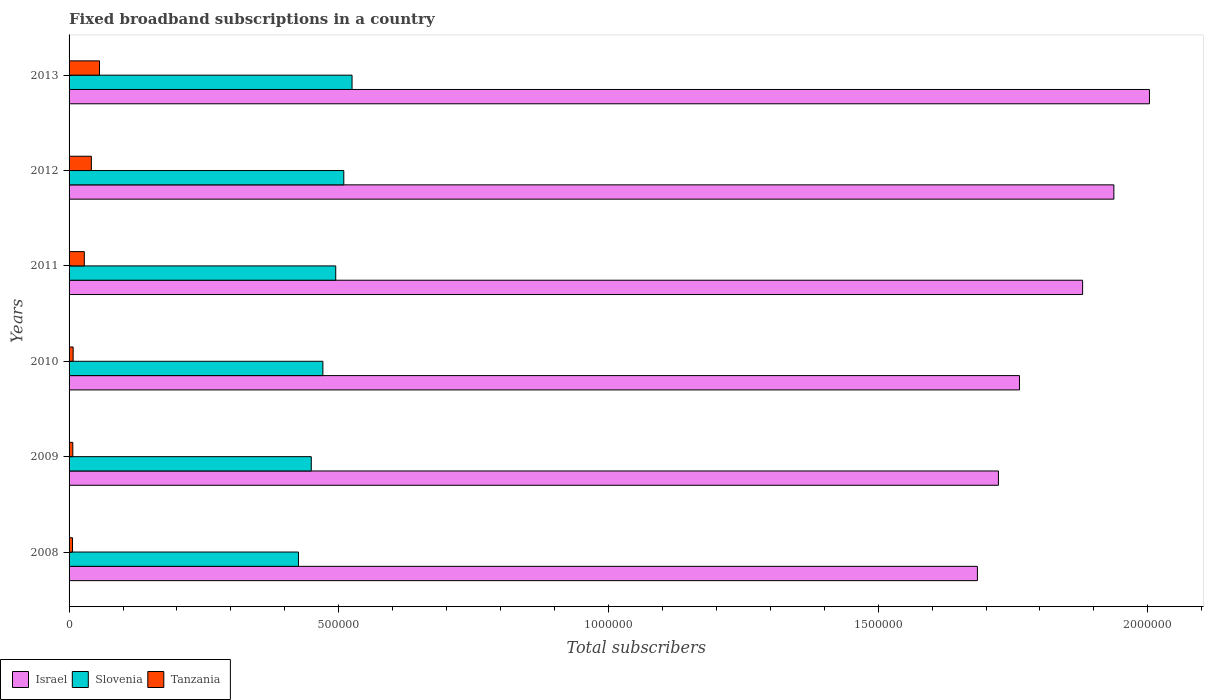How many different coloured bars are there?
Offer a terse response. 3. How many groups of bars are there?
Provide a succinct answer. 6. How many bars are there on the 6th tick from the bottom?
Give a very brief answer. 3. What is the number of broadband subscriptions in Israel in 2013?
Your answer should be very brief. 2.00e+06. Across all years, what is the maximum number of broadband subscriptions in Tanzania?
Your answer should be compact. 5.64e+04. Across all years, what is the minimum number of broadband subscriptions in Slovenia?
Provide a short and direct response. 4.25e+05. In which year was the number of broadband subscriptions in Israel minimum?
Your answer should be compact. 2008. What is the total number of broadband subscriptions in Slovenia in the graph?
Give a very brief answer. 2.87e+06. What is the difference between the number of broadband subscriptions in Slovenia in 2012 and that in 2013?
Make the answer very short. -1.53e+04. What is the difference between the number of broadband subscriptions in Slovenia in 2010 and the number of broadband subscriptions in Tanzania in 2012?
Give a very brief answer. 4.29e+05. What is the average number of broadband subscriptions in Israel per year?
Your answer should be compact. 1.83e+06. In the year 2009, what is the difference between the number of broadband subscriptions in Tanzania and number of broadband subscriptions in Slovenia?
Keep it short and to the point. -4.42e+05. In how many years, is the number of broadband subscriptions in Israel greater than 700000 ?
Provide a short and direct response. 6. What is the ratio of the number of broadband subscriptions in Israel in 2008 to that in 2010?
Provide a short and direct response. 0.96. What is the difference between the highest and the second highest number of broadband subscriptions in Israel?
Make the answer very short. 6.60e+04. What is the difference between the highest and the lowest number of broadband subscriptions in Slovenia?
Offer a very short reply. 9.93e+04. Is the sum of the number of broadband subscriptions in Tanzania in 2010 and 2013 greater than the maximum number of broadband subscriptions in Slovenia across all years?
Provide a succinct answer. No. What does the 2nd bar from the top in 2010 represents?
Keep it short and to the point. Slovenia. What does the 3rd bar from the bottom in 2010 represents?
Offer a very short reply. Tanzania. Are all the bars in the graph horizontal?
Make the answer very short. Yes. What is the difference between two consecutive major ticks on the X-axis?
Your response must be concise. 5.00e+05. Does the graph contain any zero values?
Offer a very short reply. No. Where does the legend appear in the graph?
Your answer should be very brief. Bottom left. What is the title of the graph?
Provide a short and direct response. Fixed broadband subscriptions in a country. Does "Afghanistan" appear as one of the legend labels in the graph?
Provide a short and direct response. No. What is the label or title of the X-axis?
Offer a terse response. Total subscribers. What is the Total subscribers in Israel in 2008?
Provide a short and direct response. 1.68e+06. What is the Total subscribers in Slovenia in 2008?
Keep it short and to the point. 4.25e+05. What is the Total subscribers of Tanzania in 2008?
Make the answer very short. 6422. What is the Total subscribers in Israel in 2009?
Provide a short and direct response. 1.72e+06. What is the Total subscribers in Slovenia in 2009?
Ensure brevity in your answer.  4.49e+05. What is the Total subscribers of Tanzania in 2009?
Your answer should be compact. 6947. What is the Total subscribers in Israel in 2010?
Your response must be concise. 1.76e+06. What is the Total subscribers of Slovenia in 2010?
Make the answer very short. 4.71e+05. What is the Total subscribers in Tanzania in 2010?
Give a very brief answer. 7554. What is the Total subscribers of Israel in 2011?
Offer a terse response. 1.88e+06. What is the Total subscribers of Slovenia in 2011?
Your answer should be compact. 4.94e+05. What is the Total subscribers in Tanzania in 2011?
Keep it short and to the point. 2.83e+04. What is the Total subscribers of Israel in 2012?
Offer a terse response. 1.94e+06. What is the Total subscribers in Slovenia in 2012?
Give a very brief answer. 5.09e+05. What is the Total subscribers in Tanzania in 2012?
Your answer should be compact. 4.13e+04. What is the Total subscribers of Israel in 2013?
Offer a terse response. 2.00e+06. What is the Total subscribers of Slovenia in 2013?
Make the answer very short. 5.25e+05. What is the Total subscribers of Tanzania in 2013?
Offer a terse response. 5.64e+04. Across all years, what is the maximum Total subscribers of Israel?
Your answer should be very brief. 2.00e+06. Across all years, what is the maximum Total subscribers in Slovenia?
Provide a succinct answer. 5.25e+05. Across all years, what is the maximum Total subscribers in Tanzania?
Provide a short and direct response. 5.64e+04. Across all years, what is the minimum Total subscribers in Israel?
Offer a terse response. 1.68e+06. Across all years, what is the minimum Total subscribers in Slovenia?
Provide a succinct answer. 4.25e+05. Across all years, what is the minimum Total subscribers of Tanzania?
Keep it short and to the point. 6422. What is the total Total subscribers of Israel in the graph?
Provide a short and direct response. 1.10e+07. What is the total Total subscribers of Slovenia in the graph?
Give a very brief answer. 2.87e+06. What is the total Total subscribers in Tanzania in the graph?
Your answer should be compact. 1.47e+05. What is the difference between the Total subscribers of Israel in 2008 and that in 2009?
Your response must be concise. -3.90e+04. What is the difference between the Total subscribers of Slovenia in 2008 and that in 2009?
Your answer should be very brief. -2.37e+04. What is the difference between the Total subscribers of Tanzania in 2008 and that in 2009?
Your answer should be very brief. -525. What is the difference between the Total subscribers of Israel in 2008 and that in 2010?
Keep it short and to the point. -7.80e+04. What is the difference between the Total subscribers of Slovenia in 2008 and that in 2010?
Your answer should be very brief. -4.52e+04. What is the difference between the Total subscribers in Tanzania in 2008 and that in 2010?
Offer a terse response. -1132. What is the difference between the Total subscribers in Israel in 2008 and that in 2011?
Provide a succinct answer. -1.95e+05. What is the difference between the Total subscribers of Slovenia in 2008 and that in 2011?
Make the answer very short. -6.91e+04. What is the difference between the Total subscribers of Tanzania in 2008 and that in 2011?
Make the answer very short. -2.18e+04. What is the difference between the Total subscribers in Israel in 2008 and that in 2012?
Provide a short and direct response. -2.53e+05. What is the difference between the Total subscribers of Slovenia in 2008 and that in 2012?
Offer a very short reply. -8.40e+04. What is the difference between the Total subscribers in Tanzania in 2008 and that in 2012?
Make the answer very short. -3.49e+04. What is the difference between the Total subscribers of Israel in 2008 and that in 2013?
Your response must be concise. -3.19e+05. What is the difference between the Total subscribers of Slovenia in 2008 and that in 2013?
Provide a succinct answer. -9.93e+04. What is the difference between the Total subscribers of Tanzania in 2008 and that in 2013?
Your answer should be compact. -5.00e+04. What is the difference between the Total subscribers in Israel in 2009 and that in 2010?
Offer a very short reply. -3.90e+04. What is the difference between the Total subscribers of Slovenia in 2009 and that in 2010?
Offer a very short reply. -2.15e+04. What is the difference between the Total subscribers in Tanzania in 2009 and that in 2010?
Ensure brevity in your answer.  -607. What is the difference between the Total subscribers in Israel in 2009 and that in 2011?
Your answer should be very brief. -1.56e+05. What is the difference between the Total subscribers in Slovenia in 2009 and that in 2011?
Keep it short and to the point. -4.53e+04. What is the difference between the Total subscribers in Tanzania in 2009 and that in 2011?
Offer a terse response. -2.13e+04. What is the difference between the Total subscribers of Israel in 2009 and that in 2012?
Give a very brief answer. -2.14e+05. What is the difference between the Total subscribers in Slovenia in 2009 and that in 2012?
Your answer should be compact. -6.03e+04. What is the difference between the Total subscribers of Tanzania in 2009 and that in 2012?
Provide a succinct answer. -3.44e+04. What is the difference between the Total subscribers of Israel in 2009 and that in 2013?
Your answer should be very brief. -2.80e+05. What is the difference between the Total subscribers of Slovenia in 2009 and that in 2013?
Give a very brief answer. -7.56e+04. What is the difference between the Total subscribers in Tanzania in 2009 and that in 2013?
Your response must be concise. -4.95e+04. What is the difference between the Total subscribers of Israel in 2010 and that in 2011?
Ensure brevity in your answer.  -1.17e+05. What is the difference between the Total subscribers in Slovenia in 2010 and that in 2011?
Your answer should be very brief. -2.38e+04. What is the difference between the Total subscribers of Tanzania in 2010 and that in 2011?
Offer a very short reply. -2.07e+04. What is the difference between the Total subscribers in Israel in 2010 and that in 2012?
Provide a succinct answer. -1.75e+05. What is the difference between the Total subscribers of Slovenia in 2010 and that in 2012?
Provide a succinct answer. -3.88e+04. What is the difference between the Total subscribers in Tanzania in 2010 and that in 2012?
Offer a very short reply. -3.38e+04. What is the difference between the Total subscribers of Israel in 2010 and that in 2013?
Offer a very short reply. -2.41e+05. What is the difference between the Total subscribers in Slovenia in 2010 and that in 2013?
Offer a very short reply. -5.41e+04. What is the difference between the Total subscribers of Tanzania in 2010 and that in 2013?
Your response must be concise. -4.89e+04. What is the difference between the Total subscribers in Israel in 2011 and that in 2012?
Your response must be concise. -5.80e+04. What is the difference between the Total subscribers of Slovenia in 2011 and that in 2012?
Provide a short and direct response. -1.50e+04. What is the difference between the Total subscribers in Tanzania in 2011 and that in 2012?
Your answer should be very brief. -1.31e+04. What is the difference between the Total subscribers in Israel in 2011 and that in 2013?
Provide a succinct answer. -1.24e+05. What is the difference between the Total subscribers in Slovenia in 2011 and that in 2013?
Offer a very short reply. -3.02e+04. What is the difference between the Total subscribers in Tanzania in 2011 and that in 2013?
Offer a terse response. -2.82e+04. What is the difference between the Total subscribers of Israel in 2012 and that in 2013?
Offer a terse response. -6.60e+04. What is the difference between the Total subscribers of Slovenia in 2012 and that in 2013?
Ensure brevity in your answer.  -1.53e+04. What is the difference between the Total subscribers in Tanzania in 2012 and that in 2013?
Provide a succinct answer. -1.51e+04. What is the difference between the Total subscribers of Israel in 2008 and the Total subscribers of Slovenia in 2009?
Keep it short and to the point. 1.23e+06. What is the difference between the Total subscribers of Israel in 2008 and the Total subscribers of Tanzania in 2009?
Ensure brevity in your answer.  1.68e+06. What is the difference between the Total subscribers of Slovenia in 2008 and the Total subscribers of Tanzania in 2009?
Provide a succinct answer. 4.18e+05. What is the difference between the Total subscribers of Israel in 2008 and the Total subscribers of Slovenia in 2010?
Your answer should be very brief. 1.21e+06. What is the difference between the Total subscribers of Israel in 2008 and the Total subscribers of Tanzania in 2010?
Provide a short and direct response. 1.68e+06. What is the difference between the Total subscribers of Slovenia in 2008 and the Total subscribers of Tanzania in 2010?
Give a very brief answer. 4.18e+05. What is the difference between the Total subscribers in Israel in 2008 and the Total subscribers in Slovenia in 2011?
Provide a succinct answer. 1.19e+06. What is the difference between the Total subscribers in Israel in 2008 and the Total subscribers in Tanzania in 2011?
Provide a short and direct response. 1.66e+06. What is the difference between the Total subscribers of Slovenia in 2008 and the Total subscribers of Tanzania in 2011?
Keep it short and to the point. 3.97e+05. What is the difference between the Total subscribers in Israel in 2008 and the Total subscribers in Slovenia in 2012?
Provide a succinct answer. 1.17e+06. What is the difference between the Total subscribers in Israel in 2008 and the Total subscribers in Tanzania in 2012?
Give a very brief answer. 1.64e+06. What is the difference between the Total subscribers of Slovenia in 2008 and the Total subscribers of Tanzania in 2012?
Your response must be concise. 3.84e+05. What is the difference between the Total subscribers of Israel in 2008 and the Total subscribers of Slovenia in 2013?
Offer a very short reply. 1.16e+06. What is the difference between the Total subscribers of Israel in 2008 and the Total subscribers of Tanzania in 2013?
Offer a terse response. 1.63e+06. What is the difference between the Total subscribers of Slovenia in 2008 and the Total subscribers of Tanzania in 2013?
Your answer should be very brief. 3.69e+05. What is the difference between the Total subscribers in Israel in 2009 and the Total subscribers in Slovenia in 2010?
Your answer should be very brief. 1.25e+06. What is the difference between the Total subscribers in Israel in 2009 and the Total subscribers in Tanzania in 2010?
Give a very brief answer. 1.72e+06. What is the difference between the Total subscribers in Slovenia in 2009 and the Total subscribers in Tanzania in 2010?
Keep it short and to the point. 4.41e+05. What is the difference between the Total subscribers of Israel in 2009 and the Total subscribers of Slovenia in 2011?
Your answer should be compact. 1.23e+06. What is the difference between the Total subscribers in Israel in 2009 and the Total subscribers in Tanzania in 2011?
Make the answer very short. 1.69e+06. What is the difference between the Total subscribers in Slovenia in 2009 and the Total subscribers in Tanzania in 2011?
Your answer should be very brief. 4.21e+05. What is the difference between the Total subscribers in Israel in 2009 and the Total subscribers in Slovenia in 2012?
Offer a very short reply. 1.21e+06. What is the difference between the Total subscribers in Israel in 2009 and the Total subscribers in Tanzania in 2012?
Your response must be concise. 1.68e+06. What is the difference between the Total subscribers of Slovenia in 2009 and the Total subscribers of Tanzania in 2012?
Ensure brevity in your answer.  4.08e+05. What is the difference between the Total subscribers of Israel in 2009 and the Total subscribers of Slovenia in 2013?
Your answer should be very brief. 1.20e+06. What is the difference between the Total subscribers of Israel in 2009 and the Total subscribers of Tanzania in 2013?
Provide a short and direct response. 1.67e+06. What is the difference between the Total subscribers of Slovenia in 2009 and the Total subscribers of Tanzania in 2013?
Give a very brief answer. 3.93e+05. What is the difference between the Total subscribers of Israel in 2010 and the Total subscribers of Slovenia in 2011?
Your response must be concise. 1.27e+06. What is the difference between the Total subscribers in Israel in 2010 and the Total subscribers in Tanzania in 2011?
Offer a terse response. 1.73e+06. What is the difference between the Total subscribers of Slovenia in 2010 and the Total subscribers of Tanzania in 2011?
Ensure brevity in your answer.  4.42e+05. What is the difference between the Total subscribers in Israel in 2010 and the Total subscribers in Slovenia in 2012?
Ensure brevity in your answer.  1.25e+06. What is the difference between the Total subscribers in Israel in 2010 and the Total subscribers in Tanzania in 2012?
Keep it short and to the point. 1.72e+06. What is the difference between the Total subscribers in Slovenia in 2010 and the Total subscribers in Tanzania in 2012?
Offer a terse response. 4.29e+05. What is the difference between the Total subscribers of Israel in 2010 and the Total subscribers of Slovenia in 2013?
Provide a short and direct response. 1.24e+06. What is the difference between the Total subscribers of Israel in 2010 and the Total subscribers of Tanzania in 2013?
Provide a succinct answer. 1.71e+06. What is the difference between the Total subscribers of Slovenia in 2010 and the Total subscribers of Tanzania in 2013?
Provide a short and direct response. 4.14e+05. What is the difference between the Total subscribers in Israel in 2011 and the Total subscribers in Slovenia in 2012?
Your answer should be compact. 1.37e+06. What is the difference between the Total subscribers in Israel in 2011 and the Total subscribers in Tanzania in 2012?
Give a very brief answer. 1.84e+06. What is the difference between the Total subscribers of Slovenia in 2011 and the Total subscribers of Tanzania in 2012?
Offer a terse response. 4.53e+05. What is the difference between the Total subscribers in Israel in 2011 and the Total subscribers in Slovenia in 2013?
Your answer should be very brief. 1.35e+06. What is the difference between the Total subscribers of Israel in 2011 and the Total subscribers of Tanzania in 2013?
Ensure brevity in your answer.  1.82e+06. What is the difference between the Total subscribers in Slovenia in 2011 and the Total subscribers in Tanzania in 2013?
Keep it short and to the point. 4.38e+05. What is the difference between the Total subscribers in Israel in 2012 and the Total subscribers in Slovenia in 2013?
Provide a succinct answer. 1.41e+06. What is the difference between the Total subscribers of Israel in 2012 and the Total subscribers of Tanzania in 2013?
Keep it short and to the point. 1.88e+06. What is the difference between the Total subscribers of Slovenia in 2012 and the Total subscribers of Tanzania in 2013?
Offer a very short reply. 4.53e+05. What is the average Total subscribers in Israel per year?
Give a very brief answer. 1.83e+06. What is the average Total subscribers of Slovenia per year?
Offer a very short reply. 4.79e+05. What is the average Total subscribers of Tanzania per year?
Give a very brief answer. 2.45e+04. In the year 2008, what is the difference between the Total subscribers in Israel and Total subscribers in Slovenia?
Your response must be concise. 1.26e+06. In the year 2008, what is the difference between the Total subscribers of Israel and Total subscribers of Tanzania?
Give a very brief answer. 1.68e+06. In the year 2008, what is the difference between the Total subscribers of Slovenia and Total subscribers of Tanzania?
Give a very brief answer. 4.19e+05. In the year 2009, what is the difference between the Total subscribers of Israel and Total subscribers of Slovenia?
Provide a short and direct response. 1.27e+06. In the year 2009, what is the difference between the Total subscribers in Israel and Total subscribers in Tanzania?
Your answer should be very brief. 1.72e+06. In the year 2009, what is the difference between the Total subscribers in Slovenia and Total subscribers in Tanzania?
Ensure brevity in your answer.  4.42e+05. In the year 2010, what is the difference between the Total subscribers of Israel and Total subscribers of Slovenia?
Your answer should be very brief. 1.29e+06. In the year 2010, what is the difference between the Total subscribers of Israel and Total subscribers of Tanzania?
Keep it short and to the point. 1.75e+06. In the year 2010, what is the difference between the Total subscribers in Slovenia and Total subscribers in Tanzania?
Provide a short and direct response. 4.63e+05. In the year 2011, what is the difference between the Total subscribers of Israel and Total subscribers of Slovenia?
Your answer should be very brief. 1.38e+06. In the year 2011, what is the difference between the Total subscribers of Israel and Total subscribers of Tanzania?
Your answer should be very brief. 1.85e+06. In the year 2011, what is the difference between the Total subscribers in Slovenia and Total subscribers in Tanzania?
Your response must be concise. 4.66e+05. In the year 2012, what is the difference between the Total subscribers of Israel and Total subscribers of Slovenia?
Provide a short and direct response. 1.43e+06. In the year 2012, what is the difference between the Total subscribers in Israel and Total subscribers in Tanzania?
Make the answer very short. 1.90e+06. In the year 2012, what is the difference between the Total subscribers in Slovenia and Total subscribers in Tanzania?
Give a very brief answer. 4.68e+05. In the year 2013, what is the difference between the Total subscribers in Israel and Total subscribers in Slovenia?
Offer a very short reply. 1.48e+06. In the year 2013, what is the difference between the Total subscribers of Israel and Total subscribers of Tanzania?
Make the answer very short. 1.95e+06. In the year 2013, what is the difference between the Total subscribers in Slovenia and Total subscribers in Tanzania?
Your answer should be compact. 4.68e+05. What is the ratio of the Total subscribers in Israel in 2008 to that in 2009?
Provide a succinct answer. 0.98. What is the ratio of the Total subscribers in Slovenia in 2008 to that in 2009?
Ensure brevity in your answer.  0.95. What is the ratio of the Total subscribers in Tanzania in 2008 to that in 2009?
Give a very brief answer. 0.92. What is the ratio of the Total subscribers in Israel in 2008 to that in 2010?
Offer a terse response. 0.96. What is the ratio of the Total subscribers in Slovenia in 2008 to that in 2010?
Your answer should be compact. 0.9. What is the ratio of the Total subscribers in Tanzania in 2008 to that in 2010?
Make the answer very short. 0.85. What is the ratio of the Total subscribers of Israel in 2008 to that in 2011?
Your response must be concise. 0.9. What is the ratio of the Total subscribers of Slovenia in 2008 to that in 2011?
Your response must be concise. 0.86. What is the ratio of the Total subscribers in Tanzania in 2008 to that in 2011?
Give a very brief answer. 0.23. What is the ratio of the Total subscribers in Israel in 2008 to that in 2012?
Your answer should be very brief. 0.87. What is the ratio of the Total subscribers of Slovenia in 2008 to that in 2012?
Make the answer very short. 0.83. What is the ratio of the Total subscribers of Tanzania in 2008 to that in 2012?
Ensure brevity in your answer.  0.16. What is the ratio of the Total subscribers of Israel in 2008 to that in 2013?
Your answer should be compact. 0.84. What is the ratio of the Total subscribers in Slovenia in 2008 to that in 2013?
Your answer should be very brief. 0.81. What is the ratio of the Total subscribers of Tanzania in 2008 to that in 2013?
Your answer should be compact. 0.11. What is the ratio of the Total subscribers of Israel in 2009 to that in 2010?
Your answer should be very brief. 0.98. What is the ratio of the Total subscribers in Slovenia in 2009 to that in 2010?
Make the answer very short. 0.95. What is the ratio of the Total subscribers of Tanzania in 2009 to that in 2010?
Keep it short and to the point. 0.92. What is the ratio of the Total subscribers in Israel in 2009 to that in 2011?
Your answer should be compact. 0.92. What is the ratio of the Total subscribers of Slovenia in 2009 to that in 2011?
Give a very brief answer. 0.91. What is the ratio of the Total subscribers in Tanzania in 2009 to that in 2011?
Your answer should be very brief. 0.25. What is the ratio of the Total subscribers in Israel in 2009 to that in 2012?
Offer a very short reply. 0.89. What is the ratio of the Total subscribers in Slovenia in 2009 to that in 2012?
Your answer should be compact. 0.88. What is the ratio of the Total subscribers of Tanzania in 2009 to that in 2012?
Your answer should be compact. 0.17. What is the ratio of the Total subscribers of Israel in 2009 to that in 2013?
Your answer should be very brief. 0.86. What is the ratio of the Total subscribers of Slovenia in 2009 to that in 2013?
Provide a succinct answer. 0.86. What is the ratio of the Total subscribers in Tanzania in 2009 to that in 2013?
Your answer should be very brief. 0.12. What is the ratio of the Total subscribers in Israel in 2010 to that in 2011?
Your response must be concise. 0.94. What is the ratio of the Total subscribers of Slovenia in 2010 to that in 2011?
Your answer should be compact. 0.95. What is the ratio of the Total subscribers of Tanzania in 2010 to that in 2011?
Your answer should be very brief. 0.27. What is the ratio of the Total subscribers of Israel in 2010 to that in 2012?
Offer a very short reply. 0.91. What is the ratio of the Total subscribers of Slovenia in 2010 to that in 2012?
Your response must be concise. 0.92. What is the ratio of the Total subscribers in Tanzania in 2010 to that in 2012?
Make the answer very short. 0.18. What is the ratio of the Total subscribers in Israel in 2010 to that in 2013?
Your response must be concise. 0.88. What is the ratio of the Total subscribers in Slovenia in 2010 to that in 2013?
Ensure brevity in your answer.  0.9. What is the ratio of the Total subscribers in Tanzania in 2010 to that in 2013?
Keep it short and to the point. 0.13. What is the ratio of the Total subscribers of Israel in 2011 to that in 2012?
Offer a very short reply. 0.97. What is the ratio of the Total subscribers in Slovenia in 2011 to that in 2012?
Your response must be concise. 0.97. What is the ratio of the Total subscribers of Tanzania in 2011 to that in 2012?
Your answer should be very brief. 0.68. What is the ratio of the Total subscribers of Israel in 2011 to that in 2013?
Ensure brevity in your answer.  0.94. What is the ratio of the Total subscribers of Slovenia in 2011 to that in 2013?
Your response must be concise. 0.94. What is the ratio of the Total subscribers in Tanzania in 2011 to that in 2013?
Your response must be concise. 0.5. What is the ratio of the Total subscribers of Slovenia in 2012 to that in 2013?
Give a very brief answer. 0.97. What is the ratio of the Total subscribers in Tanzania in 2012 to that in 2013?
Offer a terse response. 0.73. What is the difference between the highest and the second highest Total subscribers in Israel?
Make the answer very short. 6.60e+04. What is the difference between the highest and the second highest Total subscribers of Slovenia?
Provide a succinct answer. 1.53e+04. What is the difference between the highest and the second highest Total subscribers of Tanzania?
Give a very brief answer. 1.51e+04. What is the difference between the highest and the lowest Total subscribers in Israel?
Your response must be concise. 3.19e+05. What is the difference between the highest and the lowest Total subscribers in Slovenia?
Your answer should be compact. 9.93e+04. What is the difference between the highest and the lowest Total subscribers in Tanzania?
Your answer should be compact. 5.00e+04. 